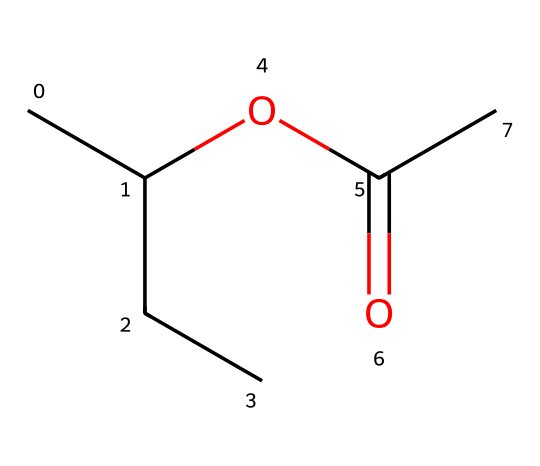How many carbon atoms are in this chemical? The SMILES representation shows "CC(CC)" indicating that there are four carbon atoms in the straight chain and one in the carbonyl group, totaling five carbon atoms.
Answer: five What functional group is present in this chemical? The presence of "OC(=O)" indicates that this chemical contains a carboxylate functional group, which consists of a carbonyl (C=O) and an ether (O) group.
Answer: carboxylate How many oxygen atoms are in the structure? Analyzing the SMILES, there is one oxygen in the ether and one in the carbonyl, resulting in a total of two oxygen atoms in this structure.
Answer: two Is this chemical likely to be hydrophilic or hydrophobic? The presence of the oxygen atoms and the functional groups in the structure suggests this chemical has the potential to interact favorably with water (hydrophilic).
Answer: hydrophilic What type of solid could this chemical form? Given its composition with functional groups that can connect through hydrogen bonding, this chemical may form a plastic-type solid, such as a polymer.
Answer: plastic-type solid What type of interactions are significant in this chemical structure? The presence of the ester functional group and its ability to create hydrogen bonds with adjacent molecules suggests that intermolecular interactions such as hydrogen bonding are significant in this chemical.
Answer: hydrogen bonding 